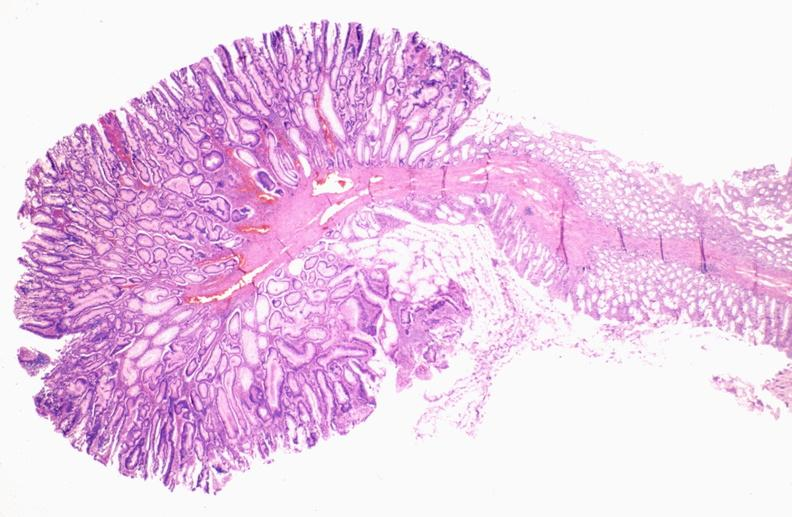what is present?
Answer the question using a single word or phrase. Gastrointestinal 